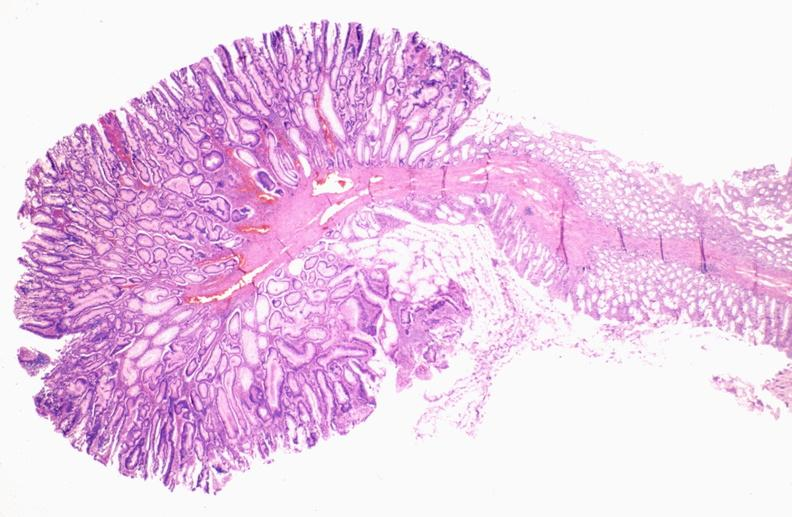what is present?
Answer the question using a single word or phrase. Gastrointestinal 